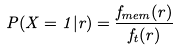<formula> <loc_0><loc_0><loc_500><loc_500>P ( X = 1 | r ) = \frac { f _ { m e m } ( r ) } { f _ { t } ( r ) }</formula> 